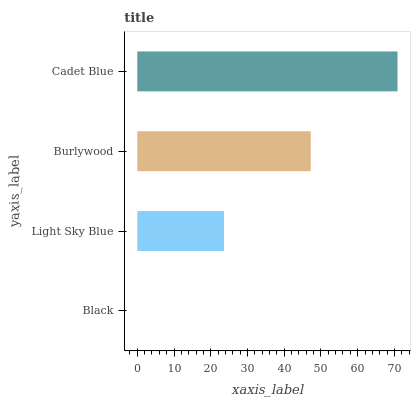Is Black the minimum?
Answer yes or no. Yes. Is Cadet Blue the maximum?
Answer yes or no. Yes. Is Light Sky Blue the minimum?
Answer yes or no. No. Is Light Sky Blue the maximum?
Answer yes or no. No. Is Light Sky Blue greater than Black?
Answer yes or no. Yes. Is Black less than Light Sky Blue?
Answer yes or no. Yes. Is Black greater than Light Sky Blue?
Answer yes or no. No. Is Light Sky Blue less than Black?
Answer yes or no. No. Is Burlywood the high median?
Answer yes or no. Yes. Is Light Sky Blue the low median?
Answer yes or no. Yes. Is Cadet Blue the high median?
Answer yes or no. No. Is Burlywood the low median?
Answer yes or no. No. 